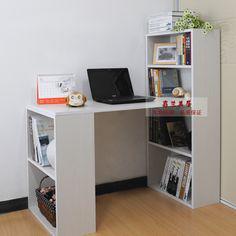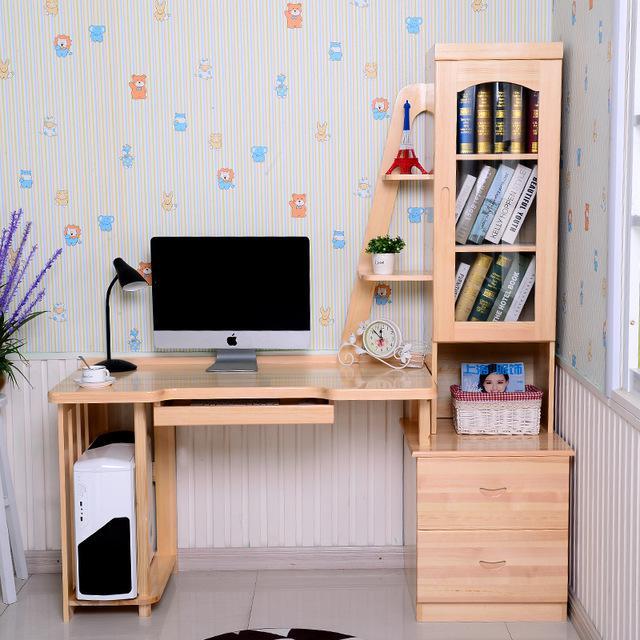The first image is the image on the left, the second image is the image on the right. For the images shown, is this caption "A desk unit in one image is comprised of a bookcase with four shelves at one end and a two-shelf bookcase at the other end, with a desktop extending between them." true? Answer yes or no. Yes. The first image is the image on the left, the second image is the image on the right. Given the left and right images, does the statement "A window is behind a white desk with a desktop computer on it and a bookshelf component against a wall." hold true? Answer yes or no. No. 